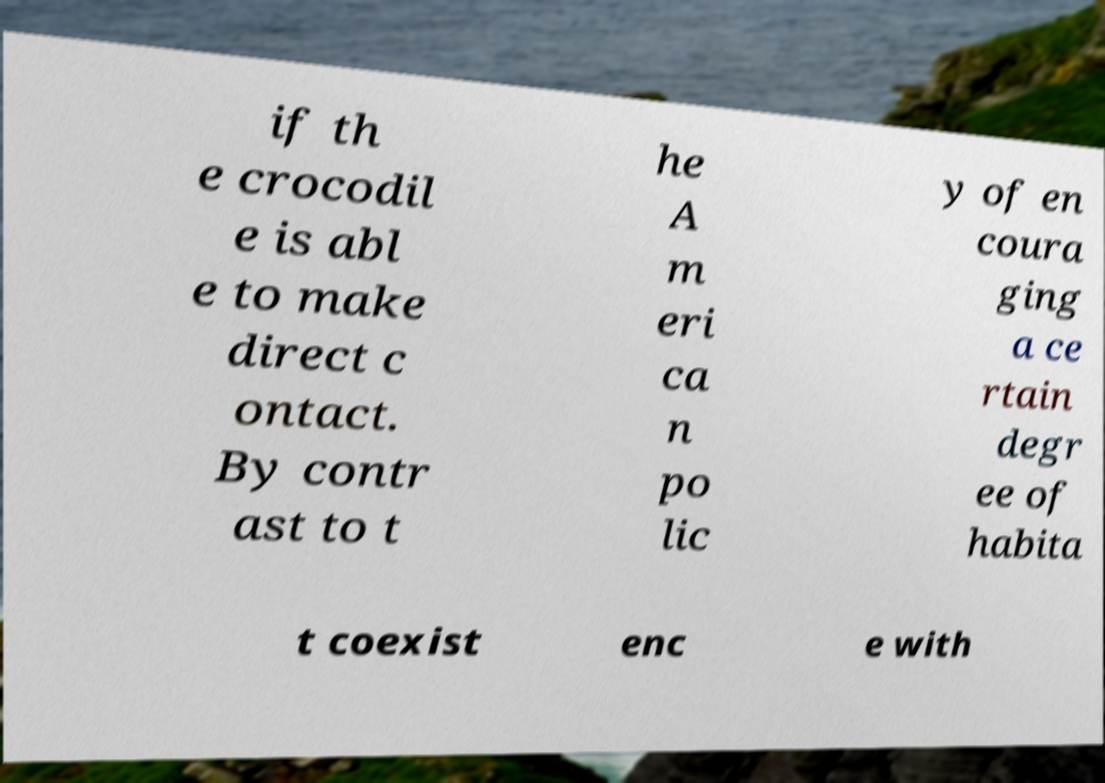Can you accurately transcribe the text from the provided image for me? if th e crocodil e is abl e to make direct c ontact. By contr ast to t he A m eri ca n po lic y of en coura ging a ce rtain degr ee of habita t coexist enc e with 